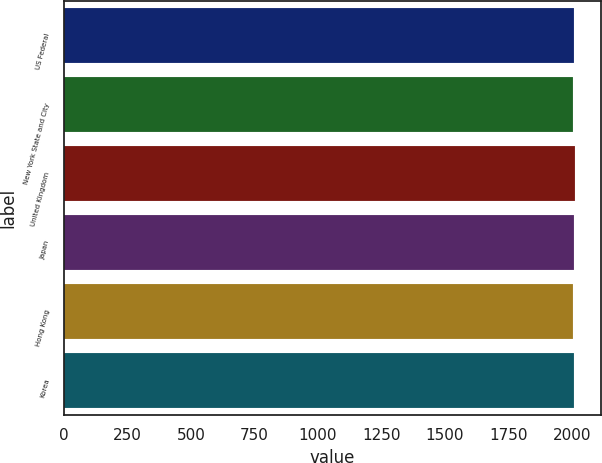<chart> <loc_0><loc_0><loc_500><loc_500><bar_chart><fcel>US Federal<fcel>New York State and City<fcel>United Kingdom<fcel>Japan<fcel>Hong Kong<fcel>Korea<nl><fcel>2008<fcel>2007<fcel>2014<fcel>2010<fcel>2006<fcel>2010.8<nl></chart> 